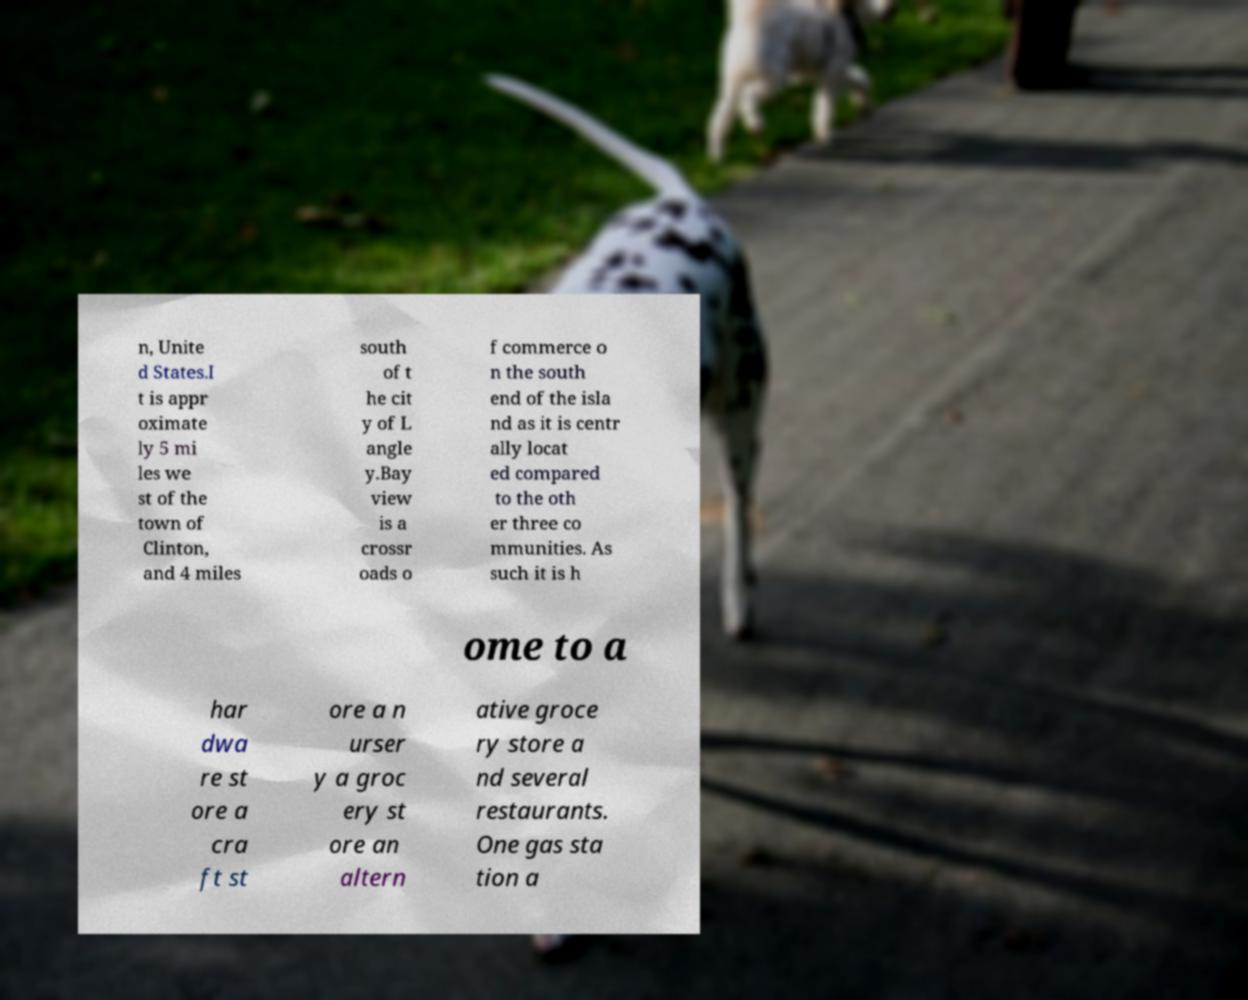Can you accurately transcribe the text from the provided image for me? n, Unite d States.I t is appr oximate ly 5 mi les we st of the town of Clinton, and 4 miles south of t he cit y of L angle y.Bay view is a crossr oads o f commerce o n the south end of the isla nd as it is centr ally locat ed compared to the oth er three co mmunities. As such it is h ome to a har dwa re st ore a cra ft st ore a n urser y a groc ery st ore an altern ative groce ry store a nd several restaurants. One gas sta tion a 